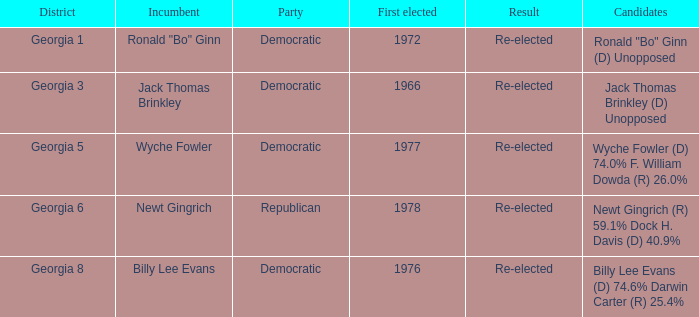Could you parse the entire table as a dict? {'header': ['District', 'Incumbent', 'Party', 'First elected', 'Result', 'Candidates'], 'rows': [['Georgia 1', 'Ronald "Bo" Ginn', 'Democratic', '1972', 'Re-elected', 'Ronald "Bo" Ginn (D) Unopposed'], ['Georgia 3', 'Jack Thomas Brinkley', 'Democratic', '1966', 'Re-elected', 'Jack Thomas Brinkley (D) Unopposed'], ['Georgia 5', 'Wyche Fowler', 'Democratic', '1977', 'Re-elected', 'Wyche Fowler (D) 74.0% F. William Dowda (R) 26.0%'], ['Georgia 6', 'Newt Gingrich', 'Republican', '1978', 'Re-elected', 'Newt Gingrich (R) 59.1% Dock H. Davis (D) 40.9%'], ['Georgia 8', 'Billy Lee Evans', 'Democratic', '1976', 'Re-elected', 'Billy Lee Evans (D) 74.6% Darwin Carter (R) 25.4%']]} What is the earliest initial election for georgia's district 1? 1972.0. 